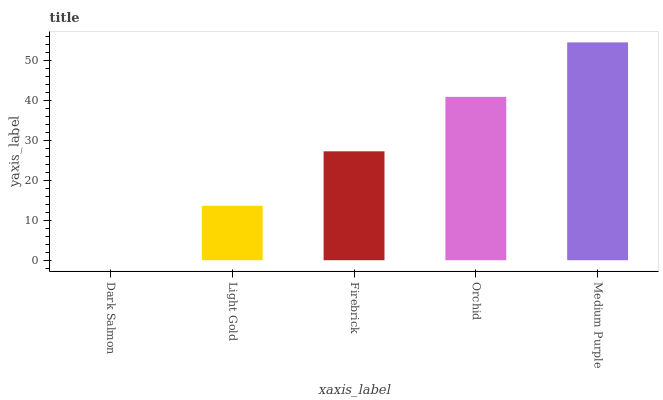Is Dark Salmon the minimum?
Answer yes or no. Yes. Is Medium Purple the maximum?
Answer yes or no. Yes. Is Light Gold the minimum?
Answer yes or no. No. Is Light Gold the maximum?
Answer yes or no. No. Is Light Gold greater than Dark Salmon?
Answer yes or no. Yes. Is Dark Salmon less than Light Gold?
Answer yes or no. Yes. Is Dark Salmon greater than Light Gold?
Answer yes or no. No. Is Light Gold less than Dark Salmon?
Answer yes or no. No. Is Firebrick the high median?
Answer yes or no. Yes. Is Firebrick the low median?
Answer yes or no. Yes. Is Light Gold the high median?
Answer yes or no. No. Is Light Gold the low median?
Answer yes or no. No. 